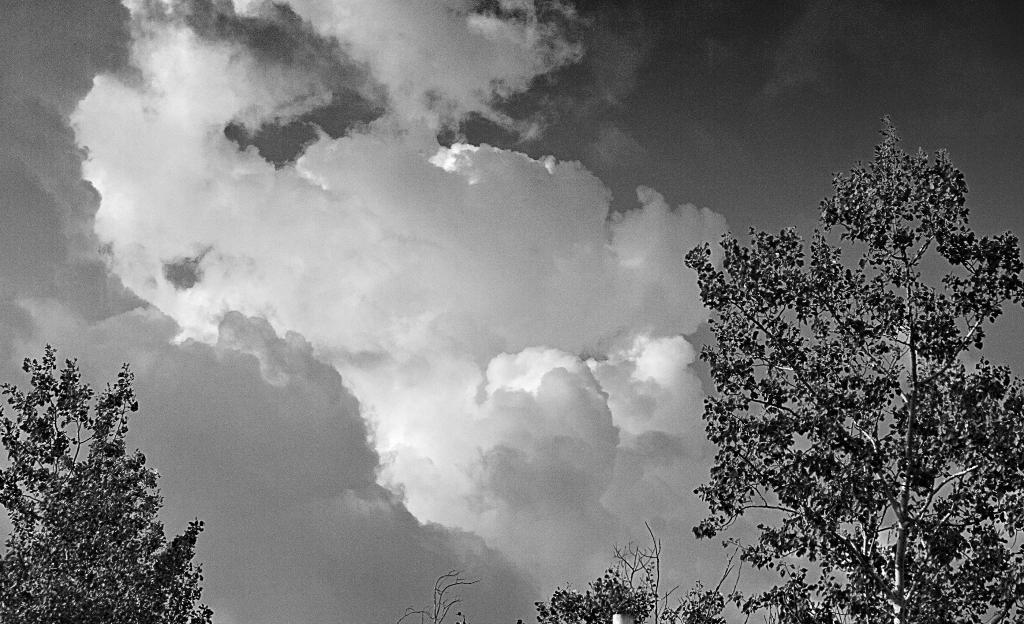What type of natural elements can be seen in the image? There are many trees in the image. What else can be seen in the sky in the image? There are clouds in the image. What part of the environment is visible in the image? The sky is visible in the image. What is the color scheme of the image? The image is black and white. What type of engine can be seen in the image? There is no engine present in the image. Is there a crook visible in the image? There is no crook present in the image. 